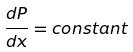Convert formula to latex. <formula><loc_0><loc_0><loc_500><loc_500>\frac { d P } { d x } = c o n s t a n t</formula> 